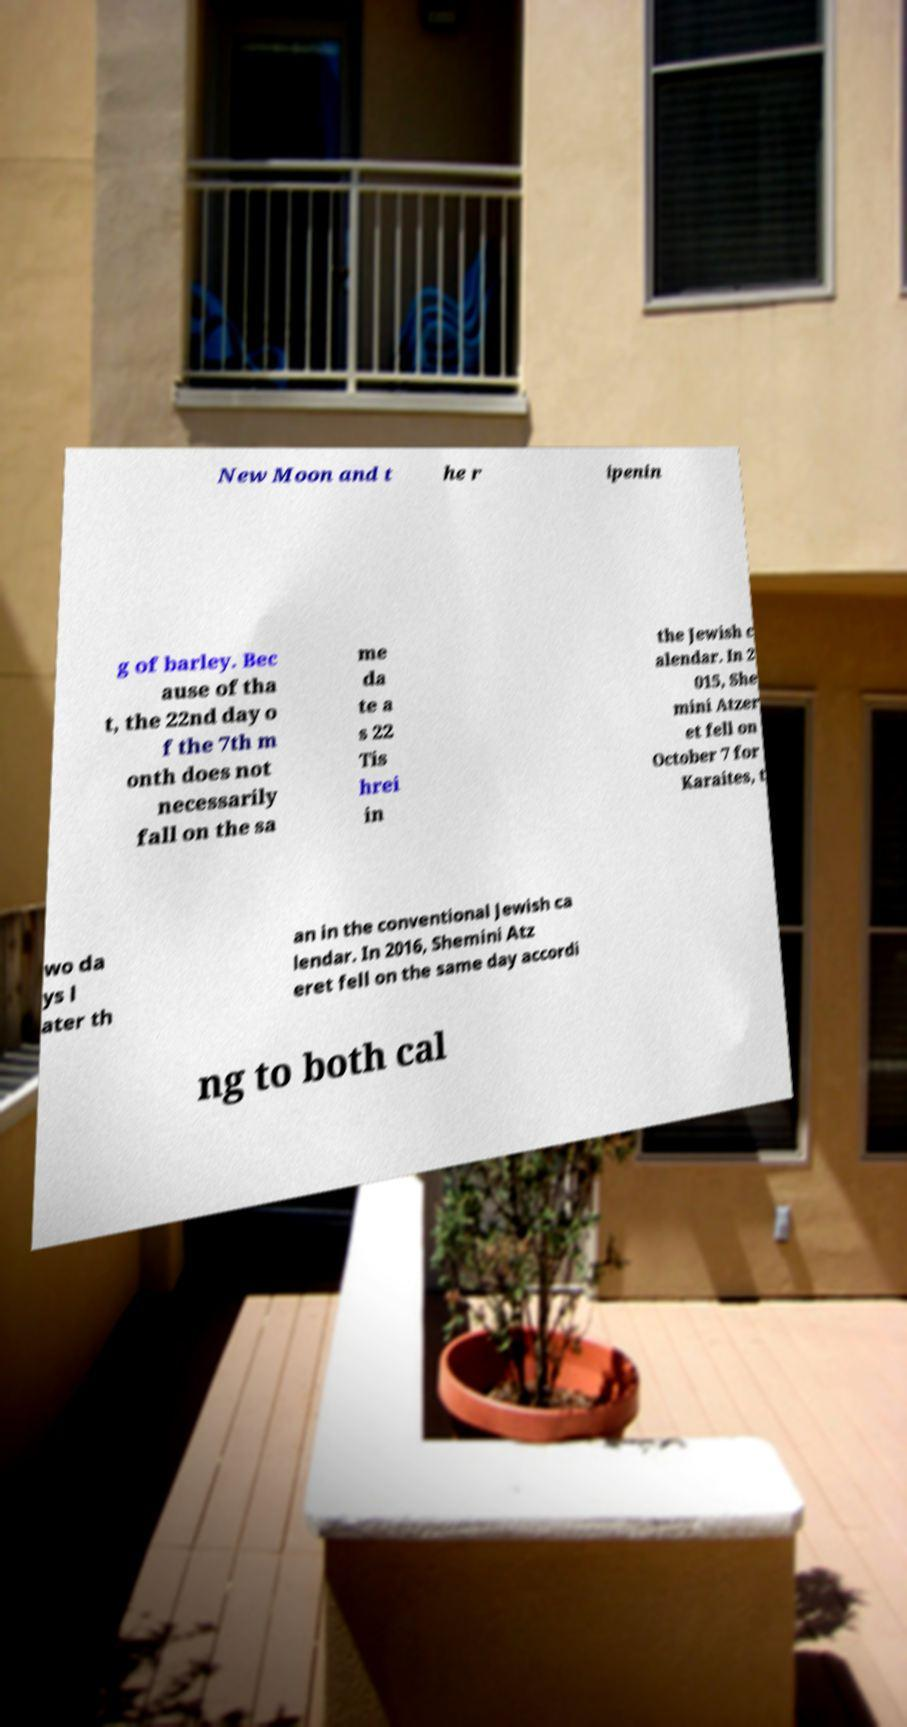Can you accurately transcribe the text from the provided image for me? New Moon and t he r ipenin g of barley. Bec ause of tha t, the 22nd day o f the 7th m onth does not necessarily fall on the sa me da te a s 22 Tis hrei in the Jewish c alendar. In 2 015, She mini Atzer et fell on October 7 for Karaites, t wo da ys l ater th an in the conventional Jewish ca lendar. In 2016, Shemini Atz eret fell on the same day accordi ng to both cal 